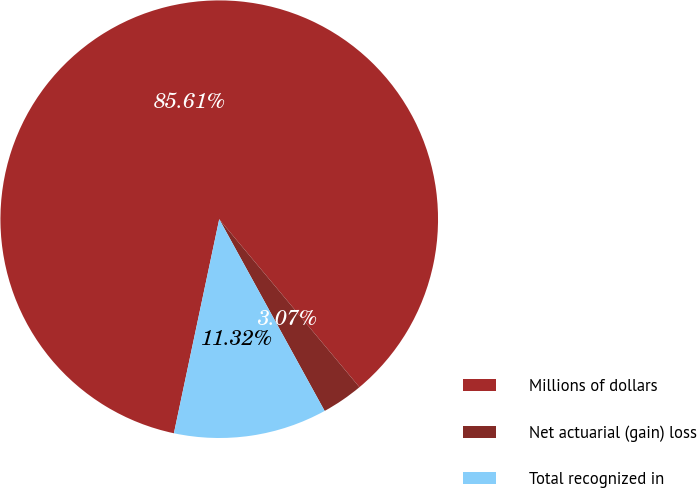Convert chart. <chart><loc_0><loc_0><loc_500><loc_500><pie_chart><fcel>Millions of dollars<fcel>Net actuarial (gain) loss<fcel>Total recognized in<nl><fcel>85.6%<fcel>3.07%<fcel>11.32%<nl></chart> 